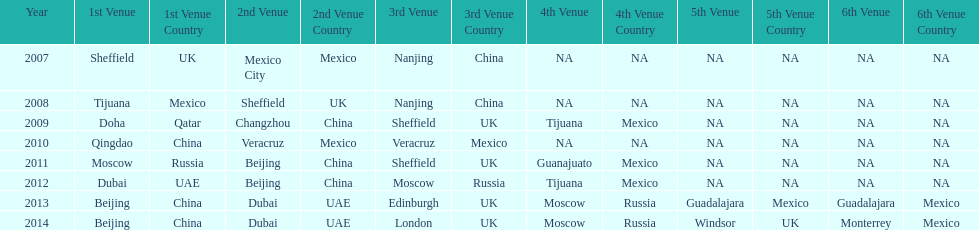Which two venue has no nations from 2007-2012 5th Venue, 6th Venue. 